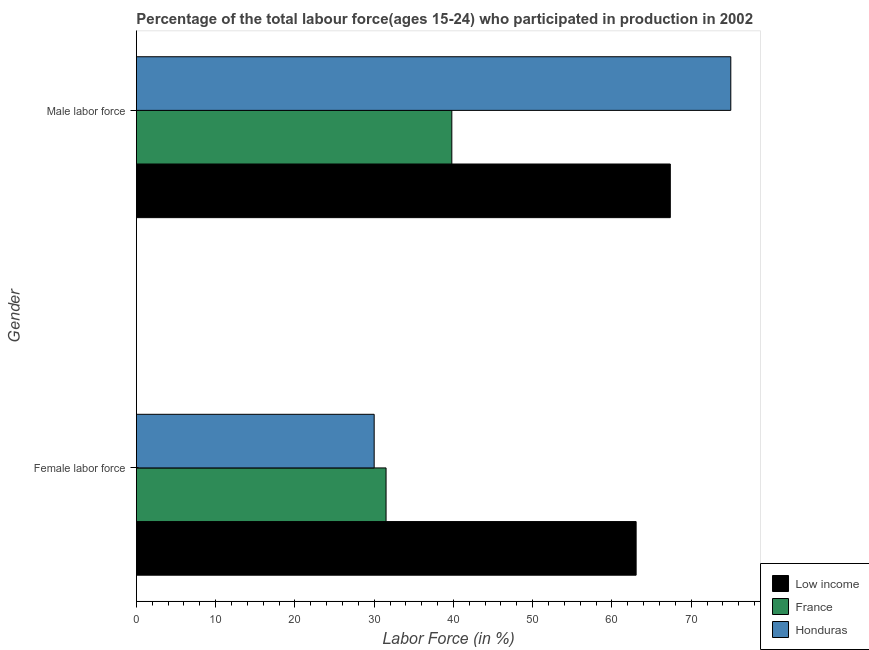How many different coloured bars are there?
Make the answer very short. 3. Are the number of bars on each tick of the Y-axis equal?
Offer a very short reply. Yes. What is the label of the 2nd group of bars from the top?
Make the answer very short. Female labor force. What is the percentage of female labor force in Low income?
Your answer should be compact. 63.06. Across all countries, what is the maximum percentage of male labour force?
Give a very brief answer. 75. In which country was the percentage of male labour force maximum?
Provide a short and direct response. Honduras. What is the total percentage of female labor force in the graph?
Provide a succinct answer. 124.56. What is the difference between the percentage of male labour force in Low income and that in Honduras?
Provide a short and direct response. -7.63. What is the difference between the percentage of female labor force in Honduras and the percentage of male labour force in France?
Offer a terse response. -9.8. What is the average percentage of female labor force per country?
Give a very brief answer. 41.52. What is the difference between the percentage of female labor force and percentage of male labour force in France?
Offer a terse response. -8.3. What is the ratio of the percentage of female labor force in Honduras to that in France?
Your response must be concise. 0.95. Is the percentage of female labor force in Honduras less than that in France?
Give a very brief answer. Yes. What does the 1st bar from the top in Male labor force represents?
Your answer should be very brief. Honduras. What does the 1st bar from the bottom in Male labor force represents?
Keep it short and to the point. Low income. How many bars are there?
Your response must be concise. 6. Are all the bars in the graph horizontal?
Make the answer very short. Yes. Are the values on the major ticks of X-axis written in scientific E-notation?
Ensure brevity in your answer.  No. Does the graph contain any zero values?
Offer a terse response. No. Does the graph contain grids?
Ensure brevity in your answer.  No. How are the legend labels stacked?
Offer a very short reply. Vertical. What is the title of the graph?
Your answer should be very brief. Percentage of the total labour force(ages 15-24) who participated in production in 2002. What is the Labor Force (in %) in Low income in Female labor force?
Make the answer very short. 63.06. What is the Labor Force (in %) of France in Female labor force?
Keep it short and to the point. 31.5. What is the Labor Force (in %) of Low income in Male labor force?
Keep it short and to the point. 67.37. What is the Labor Force (in %) of France in Male labor force?
Your response must be concise. 39.8. Across all Gender, what is the maximum Labor Force (in %) in Low income?
Provide a short and direct response. 67.37. Across all Gender, what is the maximum Labor Force (in %) in France?
Keep it short and to the point. 39.8. Across all Gender, what is the minimum Labor Force (in %) of Low income?
Give a very brief answer. 63.06. Across all Gender, what is the minimum Labor Force (in %) in France?
Ensure brevity in your answer.  31.5. What is the total Labor Force (in %) in Low income in the graph?
Provide a short and direct response. 130.42. What is the total Labor Force (in %) of France in the graph?
Your response must be concise. 71.3. What is the total Labor Force (in %) of Honduras in the graph?
Make the answer very short. 105. What is the difference between the Labor Force (in %) in Low income in Female labor force and that in Male labor force?
Ensure brevity in your answer.  -4.31. What is the difference between the Labor Force (in %) in Honduras in Female labor force and that in Male labor force?
Offer a terse response. -45. What is the difference between the Labor Force (in %) of Low income in Female labor force and the Labor Force (in %) of France in Male labor force?
Your answer should be very brief. 23.26. What is the difference between the Labor Force (in %) of Low income in Female labor force and the Labor Force (in %) of Honduras in Male labor force?
Offer a terse response. -11.94. What is the difference between the Labor Force (in %) in France in Female labor force and the Labor Force (in %) in Honduras in Male labor force?
Provide a short and direct response. -43.5. What is the average Labor Force (in %) in Low income per Gender?
Keep it short and to the point. 65.21. What is the average Labor Force (in %) in France per Gender?
Make the answer very short. 35.65. What is the average Labor Force (in %) of Honduras per Gender?
Your response must be concise. 52.5. What is the difference between the Labor Force (in %) of Low income and Labor Force (in %) of France in Female labor force?
Ensure brevity in your answer.  31.56. What is the difference between the Labor Force (in %) in Low income and Labor Force (in %) in Honduras in Female labor force?
Keep it short and to the point. 33.06. What is the difference between the Labor Force (in %) in France and Labor Force (in %) in Honduras in Female labor force?
Give a very brief answer. 1.5. What is the difference between the Labor Force (in %) of Low income and Labor Force (in %) of France in Male labor force?
Your answer should be very brief. 27.57. What is the difference between the Labor Force (in %) in Low income and Labor Force (in %) in Honduras in Male labor force?
Ensure brevity in your answer.  -7.63. What is the difference between the Labor Force (in %) in France and Labor Force (in %) in Honduras in Male labor force?
Your answer should be compact. -35.2. What is the ratio of the Labor Force (in %) in Low income in Female labor force to that in Male labor force?
Ensure brevity in your answer.  0.94. What is the ratio of the Labor Force (in %) of France in Female labor force to that in Male labor force?
Your answer should be very brief. 0.79. What is the difference between the highest and the second highest Labor Force (in %) of Low income?
Keep it short and to the point. 4.31. What is the difference between the highest and the second highest Labor Force (in %) in France?
Your response must be concise. 8.3. What is the difference between the highest and the lowest Labor Force (in %) of Low income?
Ensure brevity in your answer.  4.31. 